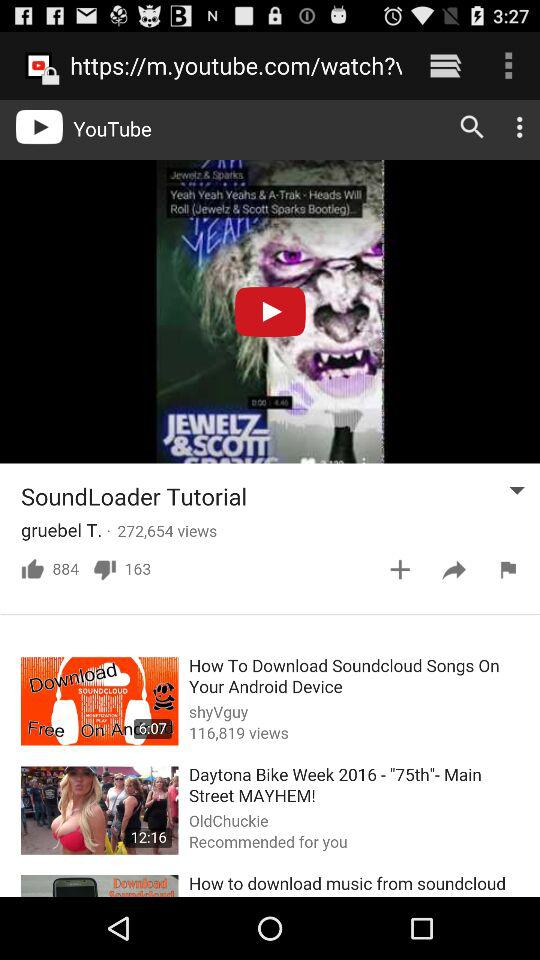What is the duration for how to download SoundCloud songs on your Android device? The duration is 6 minutes and 7 seconds. 